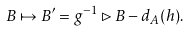Convert formula to latex. <formula><loc_0><loc_0><loc_500><loc_500>B \mapsto B ^ { \prime } = g ^ { - 1 } \rhd B - d _ { A } ( h ) .</formula> 